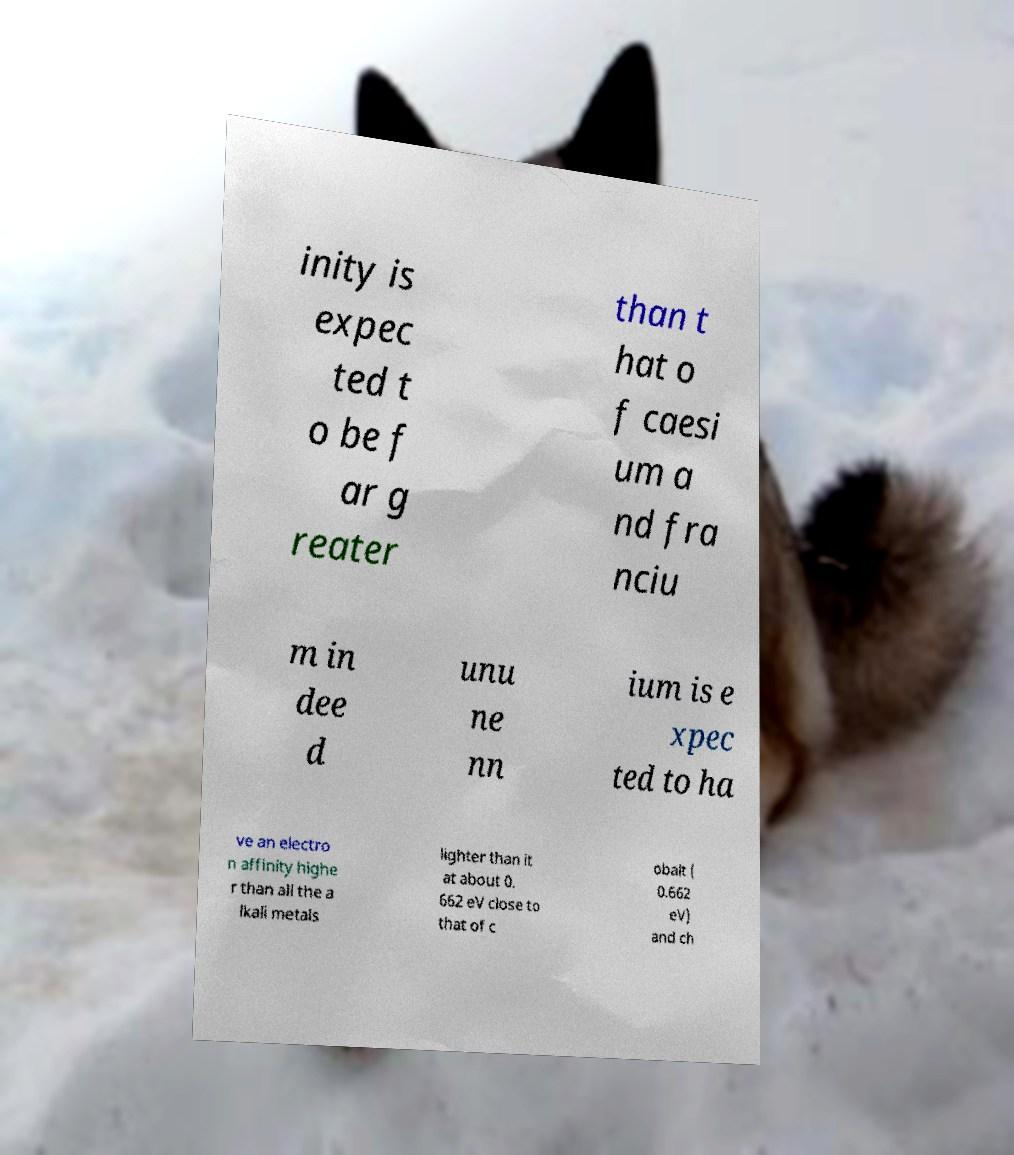Please read and relay the text visible in this image. What does it say? inity is expec ted t o be f ar g reater than t hat o f caesi um a nd fra nciu m in dee d unu ne nn ium is e xpec ted to ha ve an electro n affinity highe r than all the a lkali metals lighter than it at about 0. 662 eV close to that of c obalt ( 0.662 eV) and ch 